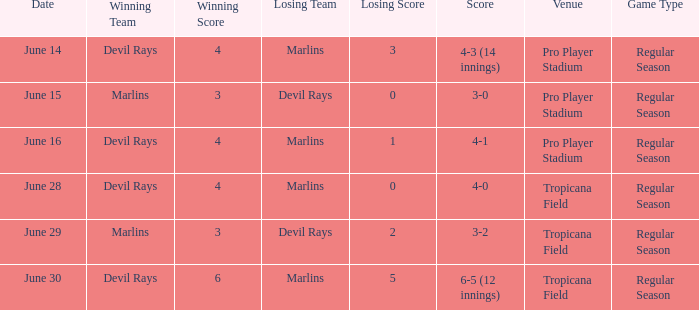What was the score on june 29 when the devil rays los? 3-2. 